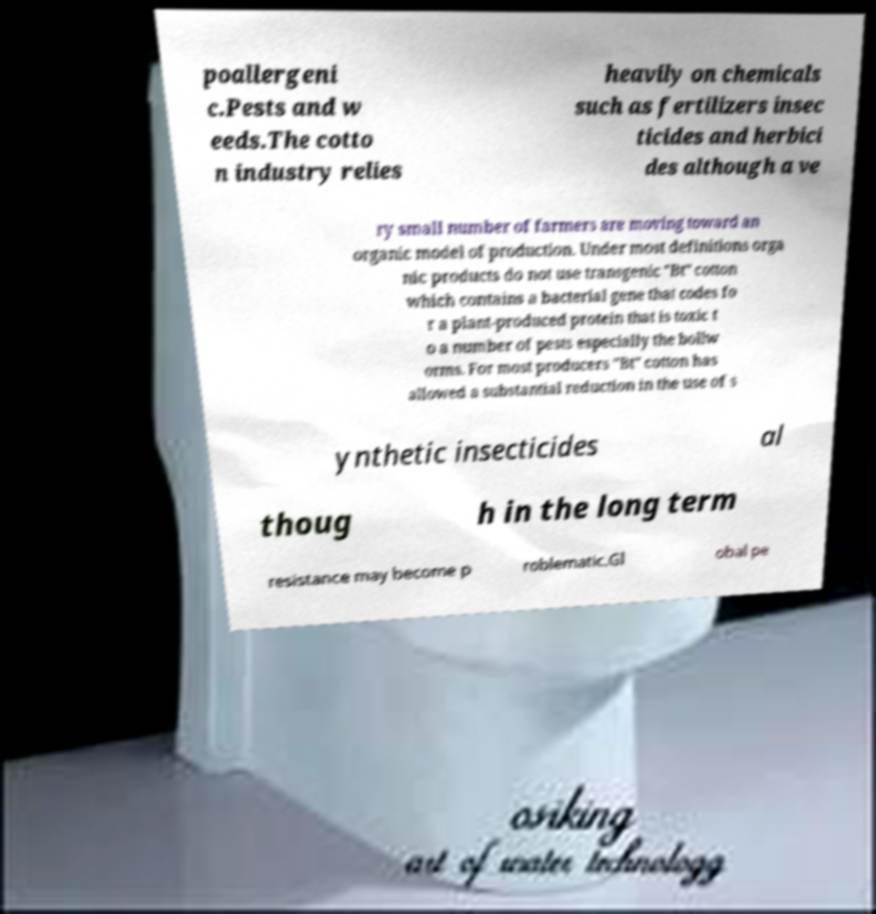Could you assist in decoding the text presented in this image and type it out clearly? poallergeni c.Pests and w eeds.The cotto n industry relies heavily on chemicals such as fertilizers insec ticides and herbici des although a ve ry small number of farmers are moving toward an organic model of production. Under most definitions orga nic products do not use transgenic "Bt" cotton which contains a bacterial gene that codes fo r a plant-produced protein that is toxic t o a number of pests especially the bollw orms. For most producers "Bt" cotton has allowed a substantial reduction in the use of s ynthetic insecticides al thoug h in the long term resistance may become p roblematic.Gl obal pe 